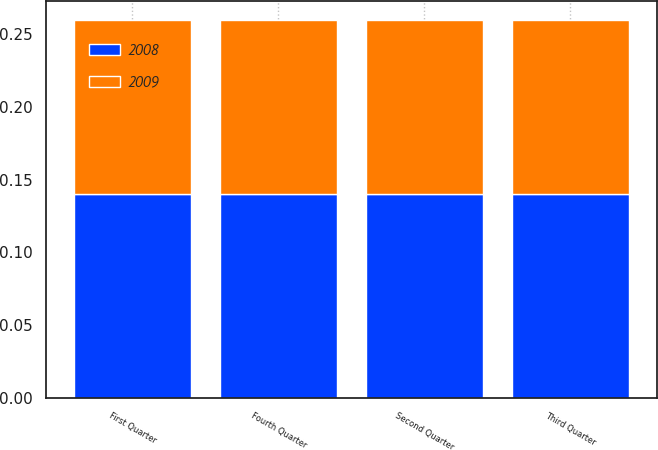Convert chart to OTSL. <chart><loc_0><loc_0><loc_500><loc_500><stacked_bar_chart><ecel><fcel>First Quarter<fcel>Second Quarter<fcel>Third Quarter<fcel>Fourth Quarter<nl><fcel>2008<fcel>0.14<fcel>0.14<fcel>0.14<fcel>0.14<nl><fcel>2009<fcel>0.12<fcel>0.12<fcel>0.12<fcel>0.12<nl></chart> 